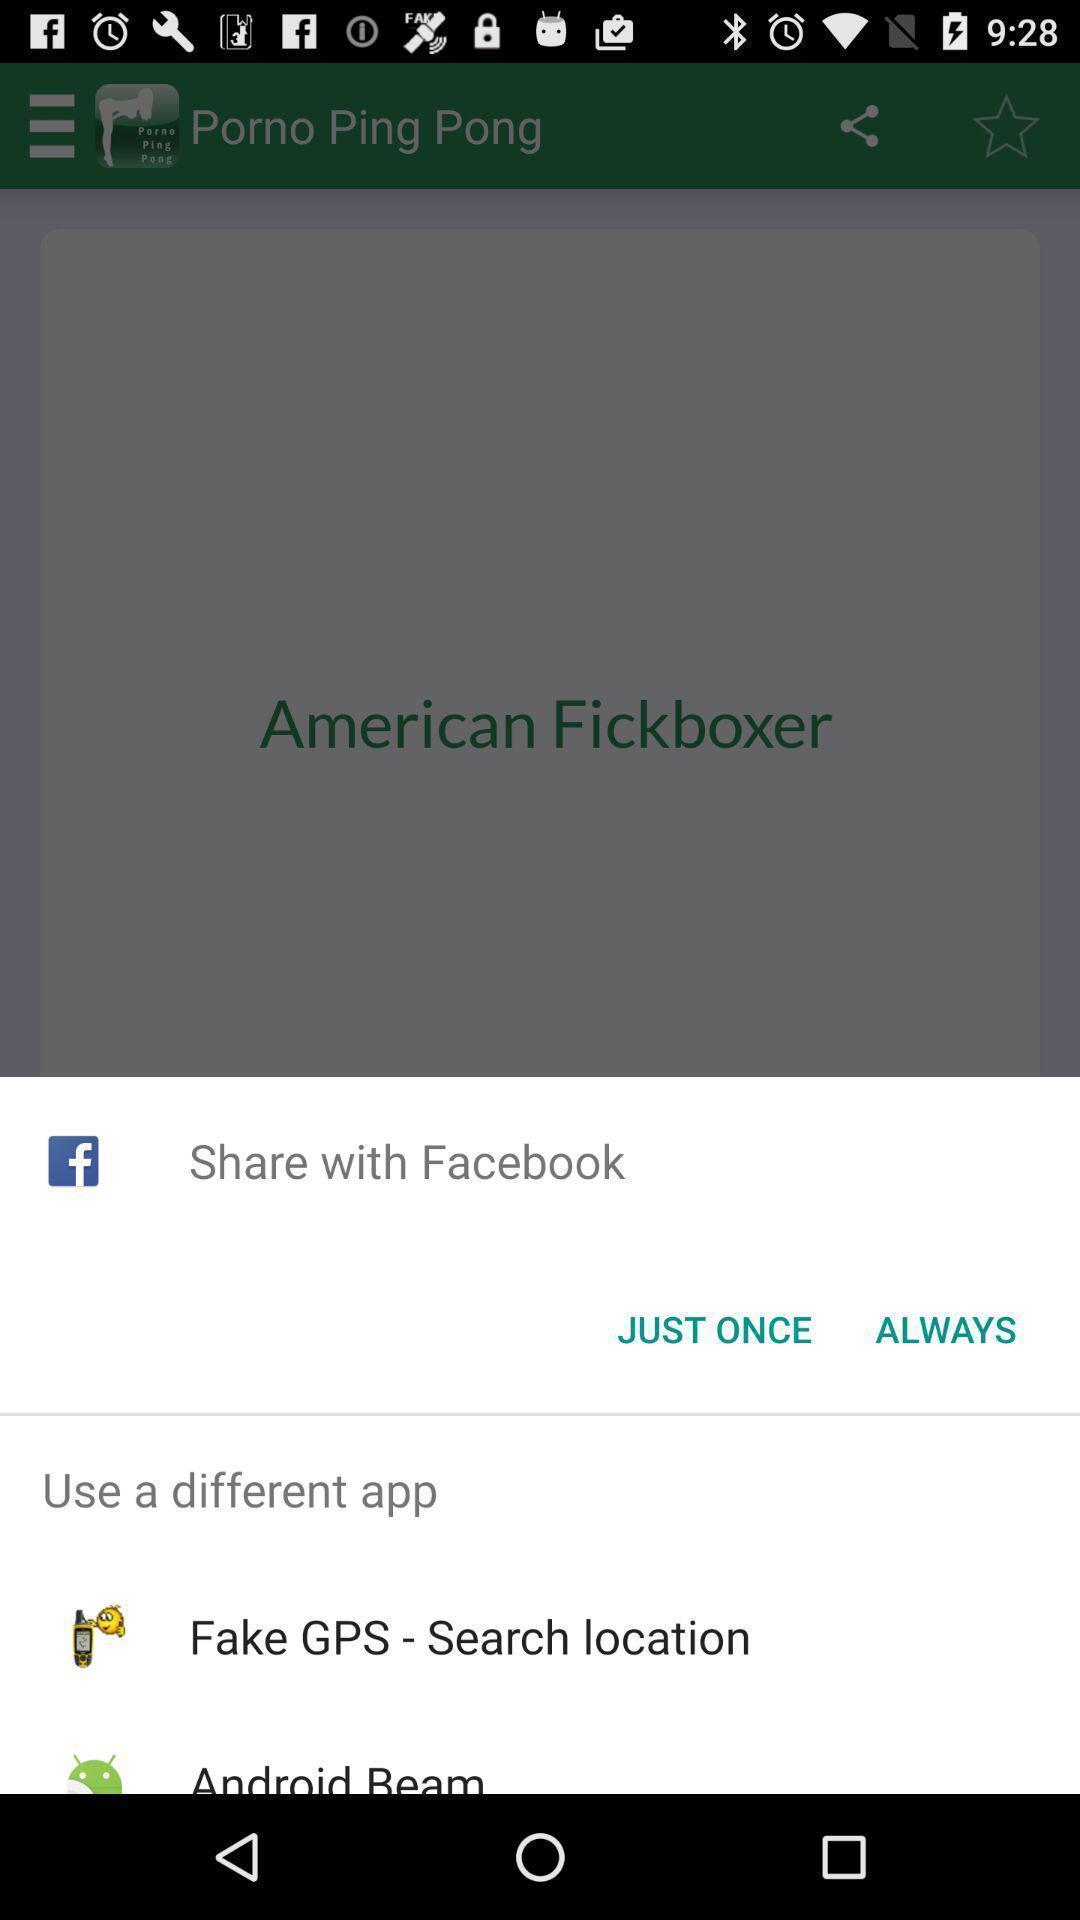Give me a narrative description of this picture. Popup showing few sharing options with icons. 